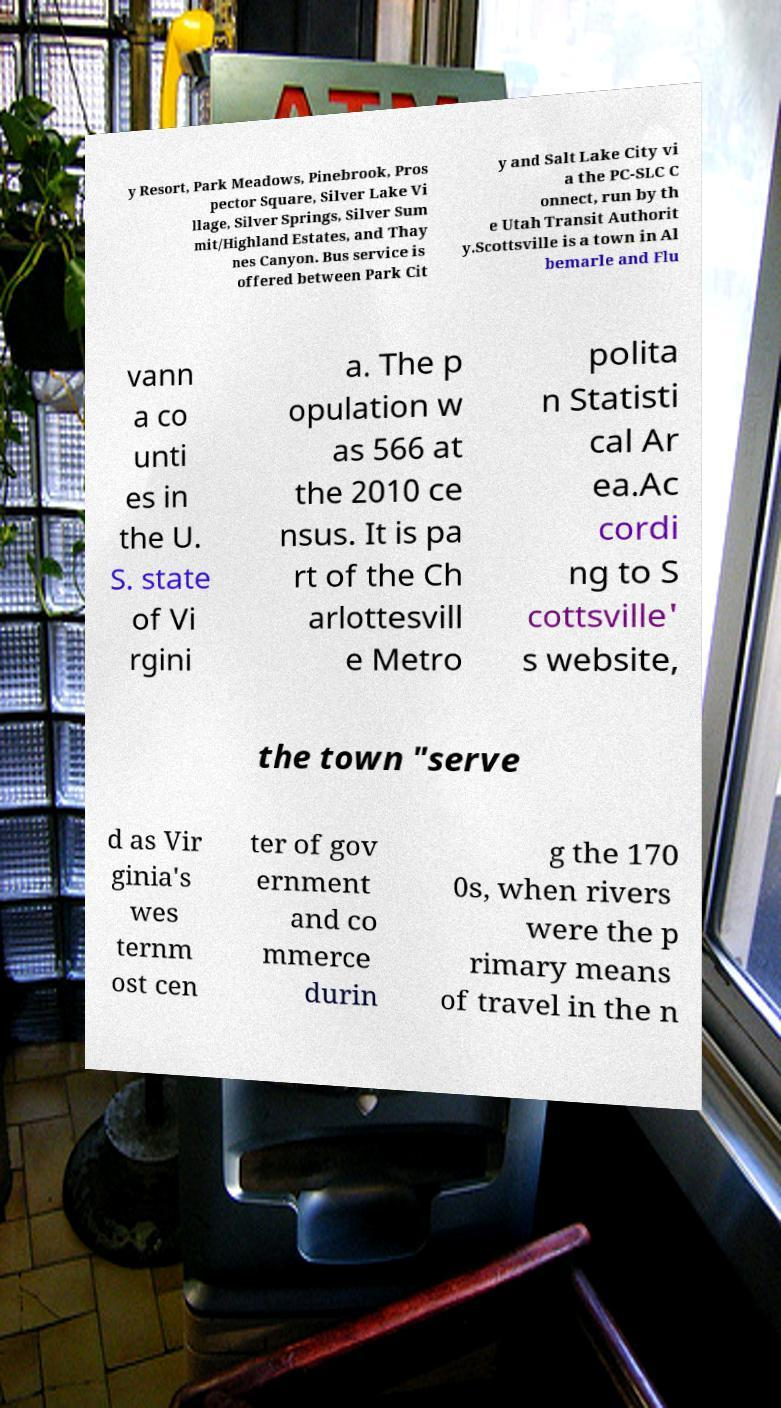Please read and relay the text visible in this image. What does it say? y Resort, Park Meadows, Pinebrook, Pros pector Square, Silver Lake Vi llage, Silver Springs, Silver Sum mit/Highland Estates, and Thay nes Canyon. Bus service is offered between Park Cit y and Salt Lake City vi a the PC-SLC C onnect, run by th e Utah Transit Authorit y.Scottsville is a town in Al bemarle and Flu vann a co unti es in the U. S. state of Vi rgini a. The p opulation w as 566 at the 2010 ce nsus. It is pa rt of the Ch arlottesvill e Metro polita n Statisti cal Ar ea.Ac cordi ng to S cottsville' s website, the town "serve d as Vir ginia's wes ternm ost cen ter of gov ernment and co mmerce durin g the 170 0s, when rivers were the p rimary means of travel in the n 